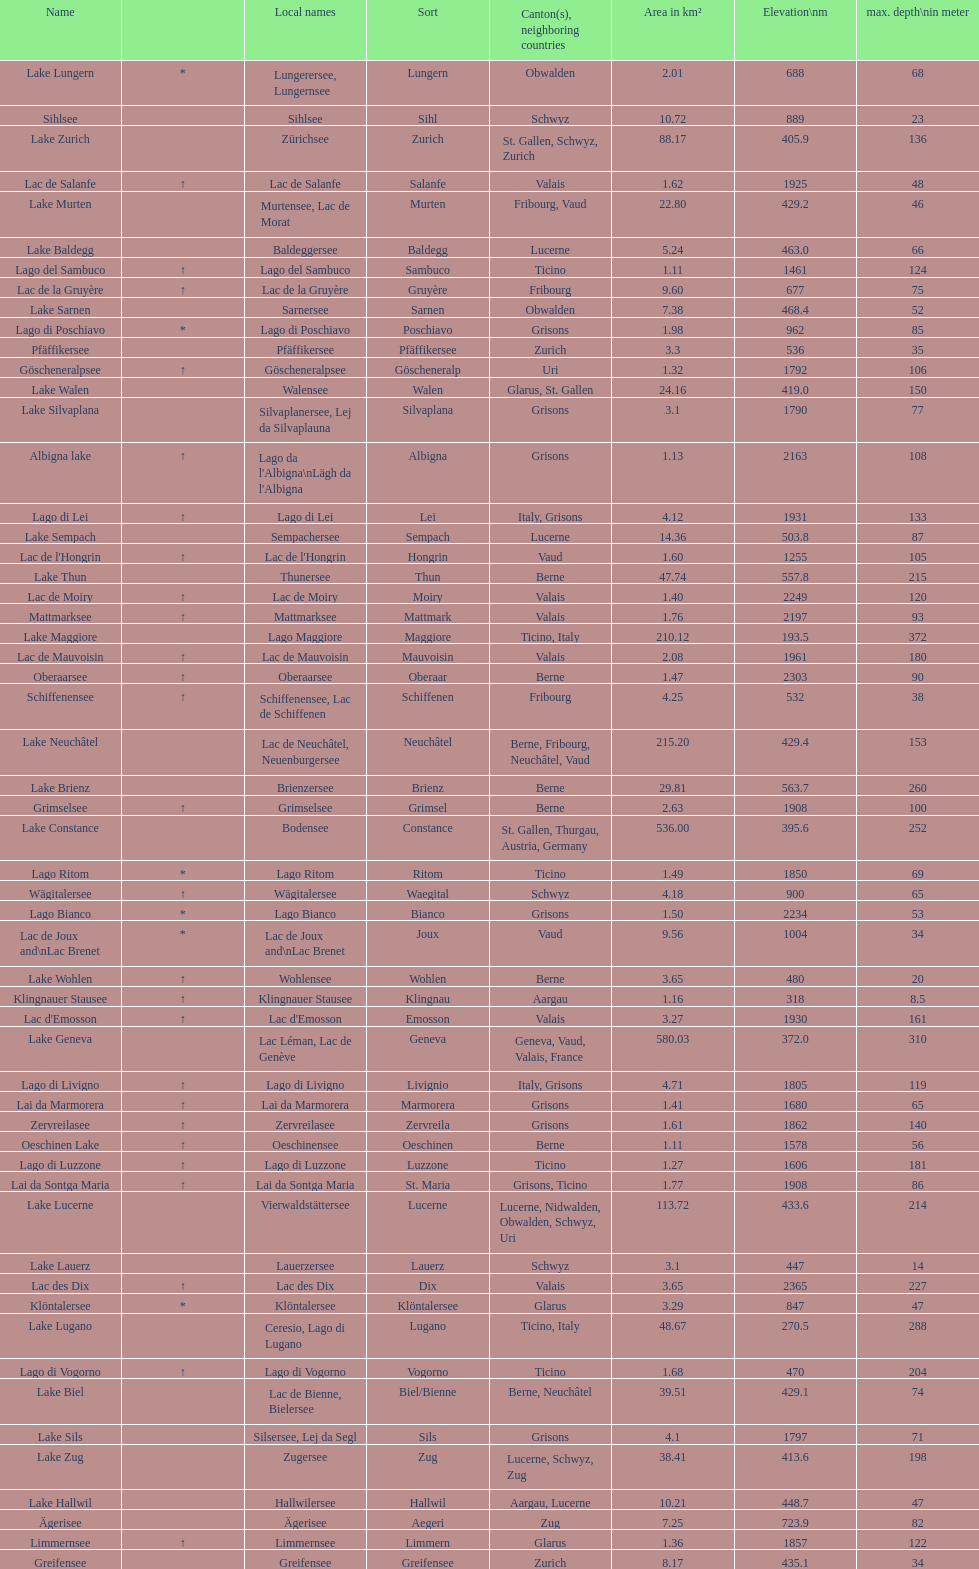What's the total max depth of lake geneva and lake constance combined? 562. 